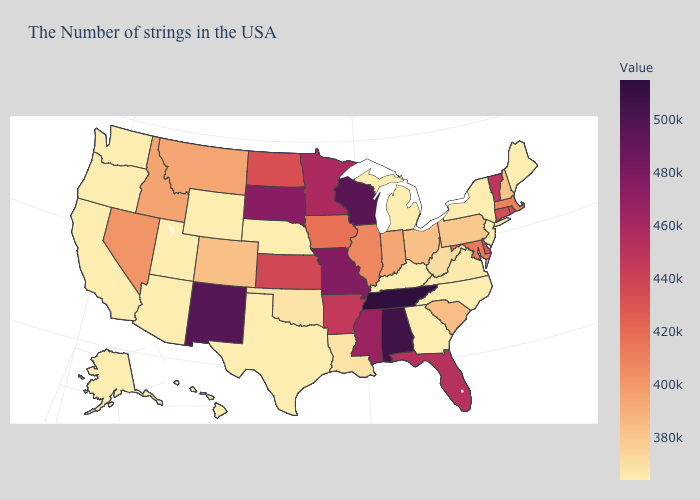Which states have the highest value in the USA?
Write a very short answer. Tennessee. Does Hawaii have the lowest value in the West?
Write a very short answer. Yes. Which states have the highest value in the USA?
Be succinct. Tennessee. Which states have the highest value in the USA?
Short answer required. Tennessee. Does Tennessee have the highest value in the USA?
Short answer required. Yes. Which states have the lowest value in the USA?
Answer briefly. Maine, New York, New Jersey, North Carolina, Georgia, Michigan, Kentucky, Nebraska, Texas, Wyoming, Utah, Arizona, California, Washington, Oregon, Alaska, Hawaii. 